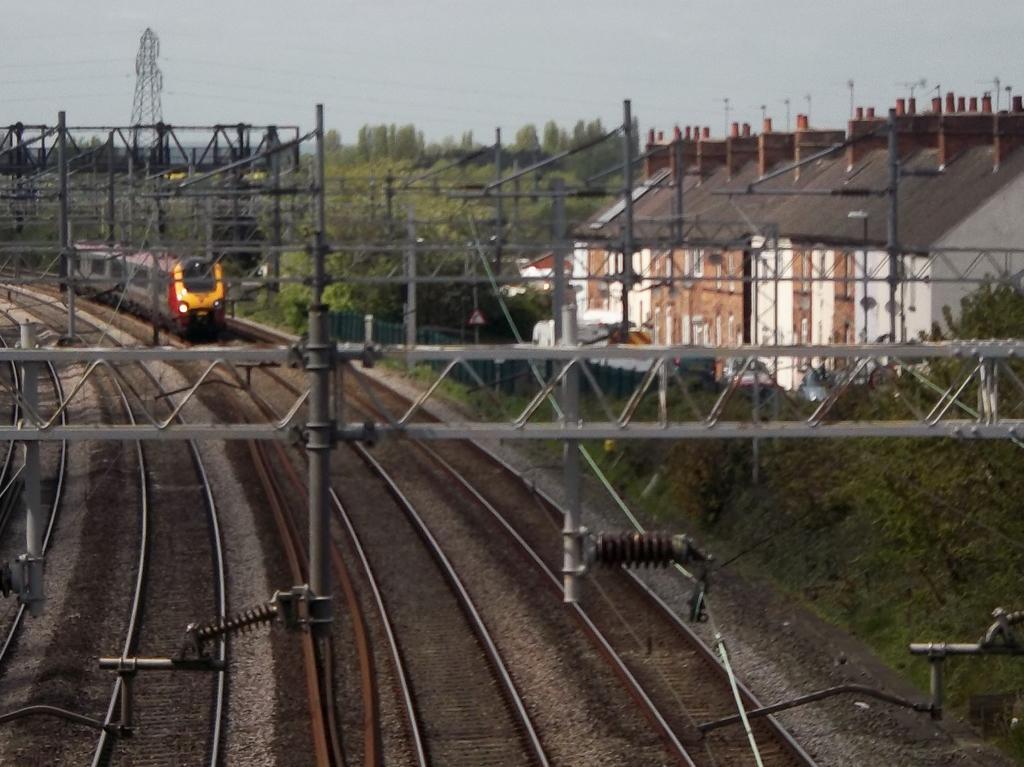Describe this image in one or two sentences. On the left side I can see the railway tracks. In the background there is a train. In the middle of the image I can see few poles and wires. On the right side there is a building and I can see many trees. At the top of the image I can see the sky. 